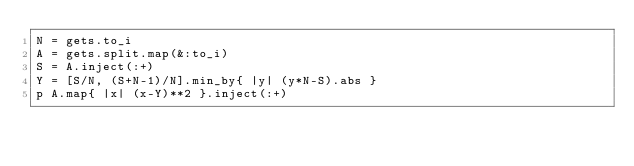Convert code to text. <code><loc_0><loc_0><loc_500><loc_500><_Ruby_>N = gets.to_i
A = gets.split.map(&:to_i)
S = A.inject(:+)
Y = [S/N, (S+N-1)/N].min_by{ |y| (y*N-S).abs }
p A.map{ |x| (x-Y)**2 }.inject(:+)
</code> 